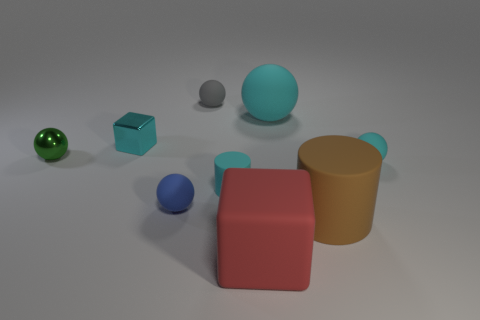How many other objects are the same color as the metallic block? Including the metallic block, there are two objects that appear to have a similar shade of blue: the block itself and the small sphere. 